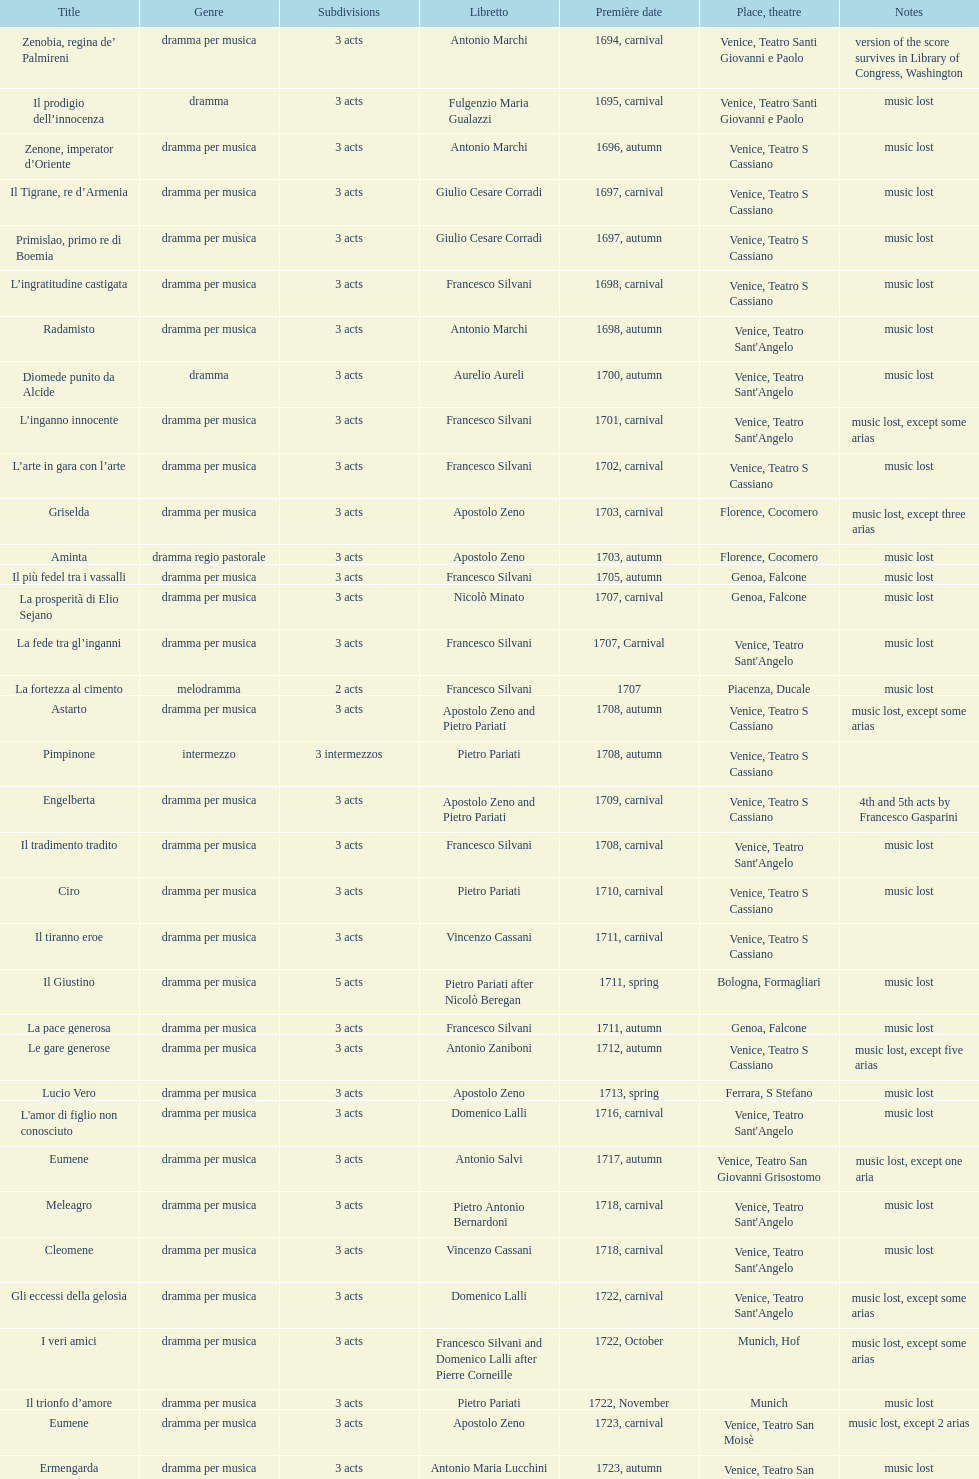How many operas on this list has at least 3 acts? 51. I'm looking to parse the entire table for insights. Could you assist me with that? {'header': ['Title', 'Genre', 'Sub\xaddivisions', 'Libretto', 'Première date', 'Place, theatre', 'Notes'], 'rows': [['Zenobia, regina de’ Palmireni', 'dramma per musica', '3 acts', 'Antonio Marchi', '1694, carnival', 'Venice, Teatro Santi Giovanni e Paolo', 'version of the score survives in Library of Congress, Washington'], ['Il prodigio dell’innocenza', 'dramma', '3 acts', 'Fulgenzio Maria Gualazzi', '1695, carnival', 'Venice, Teatro Santi Giovanni e Paolo', 'music lost'], ['Zenone, imperator d’Oriente', 'dramma per musica', '3 acts', 'Antonio Marchi', '1696, autumn', 'Venice, Teatro S Cassiano', 'music lost'], ['Il Tigrane, re d’Armenia', 'dramma per musica', '3 acts', 'Giulio Cesare Corradi', '1697, carnival', 'Venice, Teatro S Cassiano', 'music lost'], ['Primislao, primo re di Boemia', 'dramma per musica', '3 acts', 'Giulio Cesare Corradi', '1697, autumn', 'Venice, Teatro S Cassiano', 'music lost'], ['L’ingratitudine castigata', 'dramma per musica', '3 acts', 'Francesco Silvani', '1698, carnival', 'Venice, Teatro S Cassiano', 'music lost'], ['Radamisto', 'dramma per musica', '3 acts', 'Antonio Marchi', '1698, autumn', "Venice, Teatro Sant'Angelo", 'music lost'], ['Diomede punito da Alcide', 'dramma', '3 acts', 'Aurelio Aureli', '1700, autumn', "Venice, Teatro Sant'Angelo", 'music lost'], ['L’inganno innocente', 'dramma per musica', '3 acts', 'Francesco Silvani', '1701, carnival', "Venice, Teatro Sant'Angelo", 'music lost, except some arias'], ['L’arte in gara con l’arte', 'dramma per musica', '3 acts', 'Francesco Silvani', '1702, carnival', 'Venice, Teatro S Cassiano', 'music lost'], ['Griselda', 'dramma per musica', '3 acts', 'Apostolo Zeno', '1703, carnival', 'Florence, Cocomero', 'music lost, except three arias'], ['Aminta', 'dramma regio pastorale', '3 acts', 'Apostolo Zeno', '1703, autumn', 'Florence, Cocomero', 'music lost'], ['Il più fedel tra i vassalli', 'dramma per musica', '3 acts', 'Francesco Silvani', '1705, autumn', 'Genoa, Falcone', 'music lost'], ['La prosperità di Elio Sejano', 'dramma per musica', '3 acts', 'Nicolò Minato', '1707, carnival', 'Genoa, Falcone', 'music lost'], ['La fede tra gl’inganni', 'dramma per musica', '3 acts', 'Francesco Silvani', '1707, Carnival', "Venice, Teatro Sant'Angelo", 'music lost'], ['La fortezza al cimento', 'melodramma', '2 acts', 'Francesco Silvani', '1707', 'Piacenza, Ducale', 'music lost'], ['Astarto', 'dramma per musica', '3 acts', 'Apostolo Zeno and Pietro Pariati', '1708, autumn', 'Venice, Teatro S Cassiano', 'music lost, except some arias'], ['Pimpinone', 'intermezzo', '3 intermezzos', 'Pietro Pariati', '1708, autumn', 'Venice, Teatro S Cassiano', ''], ['Engelberta', 'dramma per musica', '3 acts', 'Apostolo Zeno and Pietro Pariati', '1709, carnival', 'Venice, Teatro S Cassiano', '4th and 5th acts by Francesco Gasparini'], ['Il tradimento tradito', 'dramma per musica', '3 acts', 'Francesco Silvani', '1708, carnival', "Venice, Teatro Sant'Angelo", 'music lost'], ['Ciro', 'dramma per musica', '3 acts', 'Pietro Pariati', '1710, carnival', 'Venice, Teatro S Cassiano', 'music lost'], ['Il tiranno eroe', 'dramma per musica', '3 acts', 'Vincenzo Cassani', '1711, carnival', 'Venice, Teatro S Cassiano', ''], ['Il Giustino', 'dramma per musica', '5 acts', 'Pietro Pariati after Nicolò Beregan', '1711, spring', 'Bologna, Formagliari', 'music lost'], ['La pace generosa', 'dramma per musica', '3 acts', 'Francesco Silvani', '1711, autumn', 'Genoa, Falcone', 'music lost'], ['Le gare generose', 'dramma per musica', '3 acts', 'Antonio Zaniboni', '1712, autumn', 'Venice, Teatro S Cassiano', 'music lost, except five arias'], ['Lucio Vero', 'dramma per musica', '3 acts', 'Apostolo Zeno', '1713, spring', 'Ferrara, S Stefano', 'music lost'], ["L'amor di figlio non conosciuto", 'dramma per musica', '3 acts', 'Domenico Lalli', '1716, carnival', "Venice, Teatro Sant'Angelo", 'music lost'], ['Eumene', 'dramma per musica', '3 acts', 'Antonio Salvi', '1717, autumn', 'Venice, Teatro San Giovanni Grisostomo', 'music lost, except one aria'], ['Meleagro', 'dramma per musica', '3 acts', 'Pietro Antonio Bernardoni', '1718, carnival', "Venice, Teatro Sant'Angelo", 'music lost'], ['Cleomene', 'dramma per musica', '3 acts', 'Vincenzo Cassani', '1718, carnival', "Venice, Teatro Sant'Angelo", 'music lost'], ['Gli eccessi della gelosia', 'dramma per musica', '3 acts', 'Domenico Lalli', '1722, carnival', "Venice, Teatro Sant'Angelo", 'music lost, except some arias'], ['I veri amici', 'dramma per musica', '3 acts', 'Francesco Silvani and Domenico Lalli after Pierre Corneille', '1722, October', 'Munich, Hof', 'music lost, except some arias'], ['Il trionfo d’amore', 'dramma per musica', '3 acts', 'Pietro Pariati', '1722, November', 'Munich', 'music lost'], ['Eumene', 'dramma per musica', '3 acts', 'Apostolo Zeno', '1723, carnival', 'Venice, Teatro San Moisè', 'music lost, except 2 arias'], ['Ermengarda', 'dramma per musica', '3 acts', 'Antonio Maria Lucchini', '1723, autumn', 'Venice, Teatro San Moisè', 'music lost'], ['Antigono, tutore di Filippo, re di Macedonia', 'tragedia', '5 acts', 'Giovanni Piazzon', '1724, carnival', 'Venice, Teatro San Moisè', '5th act by Giovanni Porta, music lost'], ['Scipione nelle Spagne', 'dramma per musica', '3 acts', 'Apostolo Zeno', '1724, Ascension', 'Venice, Teatro San Samuele', 'music lost'], ['Laodice', 'dramma per musica', '3 acts', 'Angelo Schietti', '1724, autumn', 'Venice, Teatro San Moisè', 'music lost, except 2 arias'], ['Didone abbandonata', 'tragedia', '3 acts', 'Metastasio', '1725, carnival', 'Venice, Teatro S Cassiano', 'music lost'], ["L'impresario delle Isole Canarie", 'intermezzo', '2 acts', 'Metastasio', '1725, carnival', 'Venice, Teatro S Cassiano', 'music lost'], ['Alcina delusa da Ruggero', 'dramma per musica', '3 acts', 'Antonio Marchi', '1725, autumn', 'Venice, Teatro S Cassiano', 'music lost'], ['I rivali generosi', 'dramma per musica', '3 acts', 'Apostolo Zeno', '1725', 'Brescia, Nuovo', ''], ['La Statira', 'dramma per musica', '3 acts', 'Apostolo Zeno and Pietro Pariati', '1726, Carnival', 'Rome, Teatro Capranica', ''], ['Malsazio e Fiammetta', 'intermezzo', '', '', '1726, Carnival', 'Rome, Teatro Capranica', ''], ['Il trionfo di Armida', 'dramma per musica', '3 acts', 'Girolamo Colatelli after Torquato Tasso', '1726, autumn', 'Venice, Teatro San Moisè', 'music lost'], ['L’incostanza schernita', 'dramma comico-pastorale', '3 acts', 'Vincenzo Cassani', '1727, Ascension', 'Venice, Teatro San Samuele', 'music lost, except some arias'], ['Le due rivali in amore', 'dramma per musica', '3 acts', 'Aurelio Aureli', '1728, autumn', 'Venice, Teatro San Moisè', 'music lost'], ['Il Satrapone', 'intermezzo', '', 'Salvi', '1729', 'Parma, Omodeo', ''], ['Li stratagemmi amorosi', 'dramma per musica', '3 acts', 'F Passerini', '1730, carnival', 'Venice, Teatro San Moisè', 'music lost'], ['Elenia', 'dramma per musica', '3 acts', 'Luisa Bergalli', '1730, carnival', "Venice, Teatro Sant'Angelo", 'music lost'], ['Merope', 'dramma', '3 acts', 'Apostolo Zeno', '1731, autumn', 'Prague, Sporck Theater', 'mostly by Albinoni, music lost'], ['Il più infedel tra gli amanti', 'dramma per musica', '3 acts', 'Angelo Schietti', '1731, autumn', 'Treviso, Dolphin', 'music lost'], ['Ardelinda', 'dramma', '3 acts', 'Bartolomeo Vitturi', '1732, autumn', "Venice, Teatro Sant'Angelo", 'music lost, except five arias'], ['Candalide', 'dramma per musica', '3 acts', 'Bartolomeo Vitturi', '1734, carnival', "Venice, Teatro Sant'Angelo", 'music lost'], ['Artamene', 'dramma per musica', '3 acts', 'Bartolomeo Vitturi', '1741, carnival', "Venice, Teatro Sant'Angelo", 'music lost']]} 